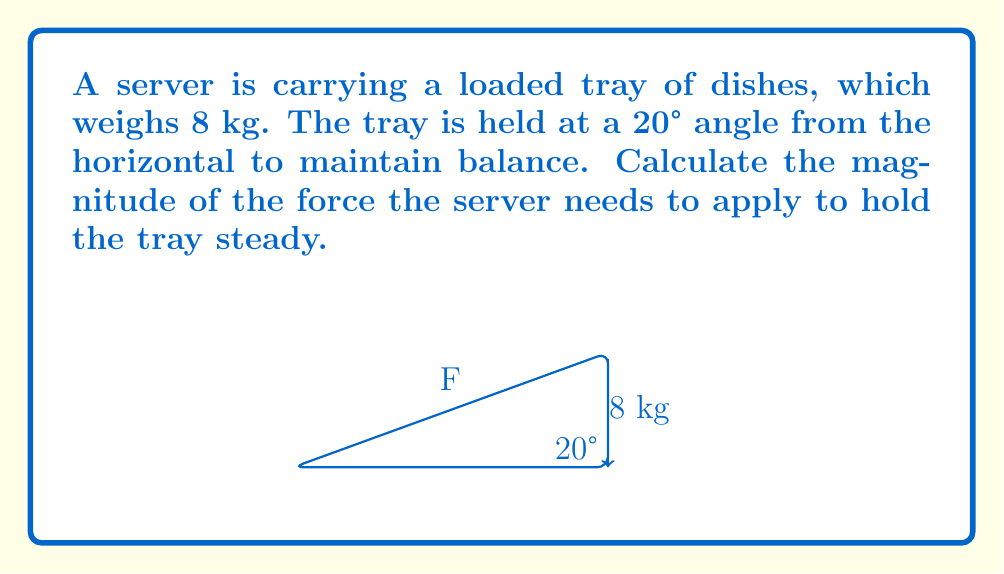Can you solve this math problem? To solve this problem, we'll use vector decomposition and the concept of static equilibrium. Here's a step-by-step approach:

1) First, we need to consider the forces acting on the tray:
   - The weight of the tray (W), acting downwards
   - The force applied by the server (F), perpendicular to the tray

2) The weight of the tray:
   $W = mg = 8 \text{ kg} \times 9.8 \text{ m/s}^2 = 78.4 \text{ N}$

3) We need to decompose this weight into components parallel and perpendicular to the tray:
   - Parallel component: $W_{\parallel} = W \sin(20°)$
   - Perpendicular component: $W_{\perp} = W \cos(20°)$

4) For the tray to be in equilibrium, the force applied by the server must equal the perpendicular component of the weight:

   $F = W_{\perp} = W \cos(20°)$

5) Let's calculate this force:
   $F = 78.4 \text{ N} \times \cos(20°)$
   $F = 78.4 \text{ N} \times 0.9397$
   $F = 73.67 \text{ N}$

6) Rounding to two decimal places:
   $F \approx 73.67 \text{ N}$
Answer: $73.67 \text{ N}$ 